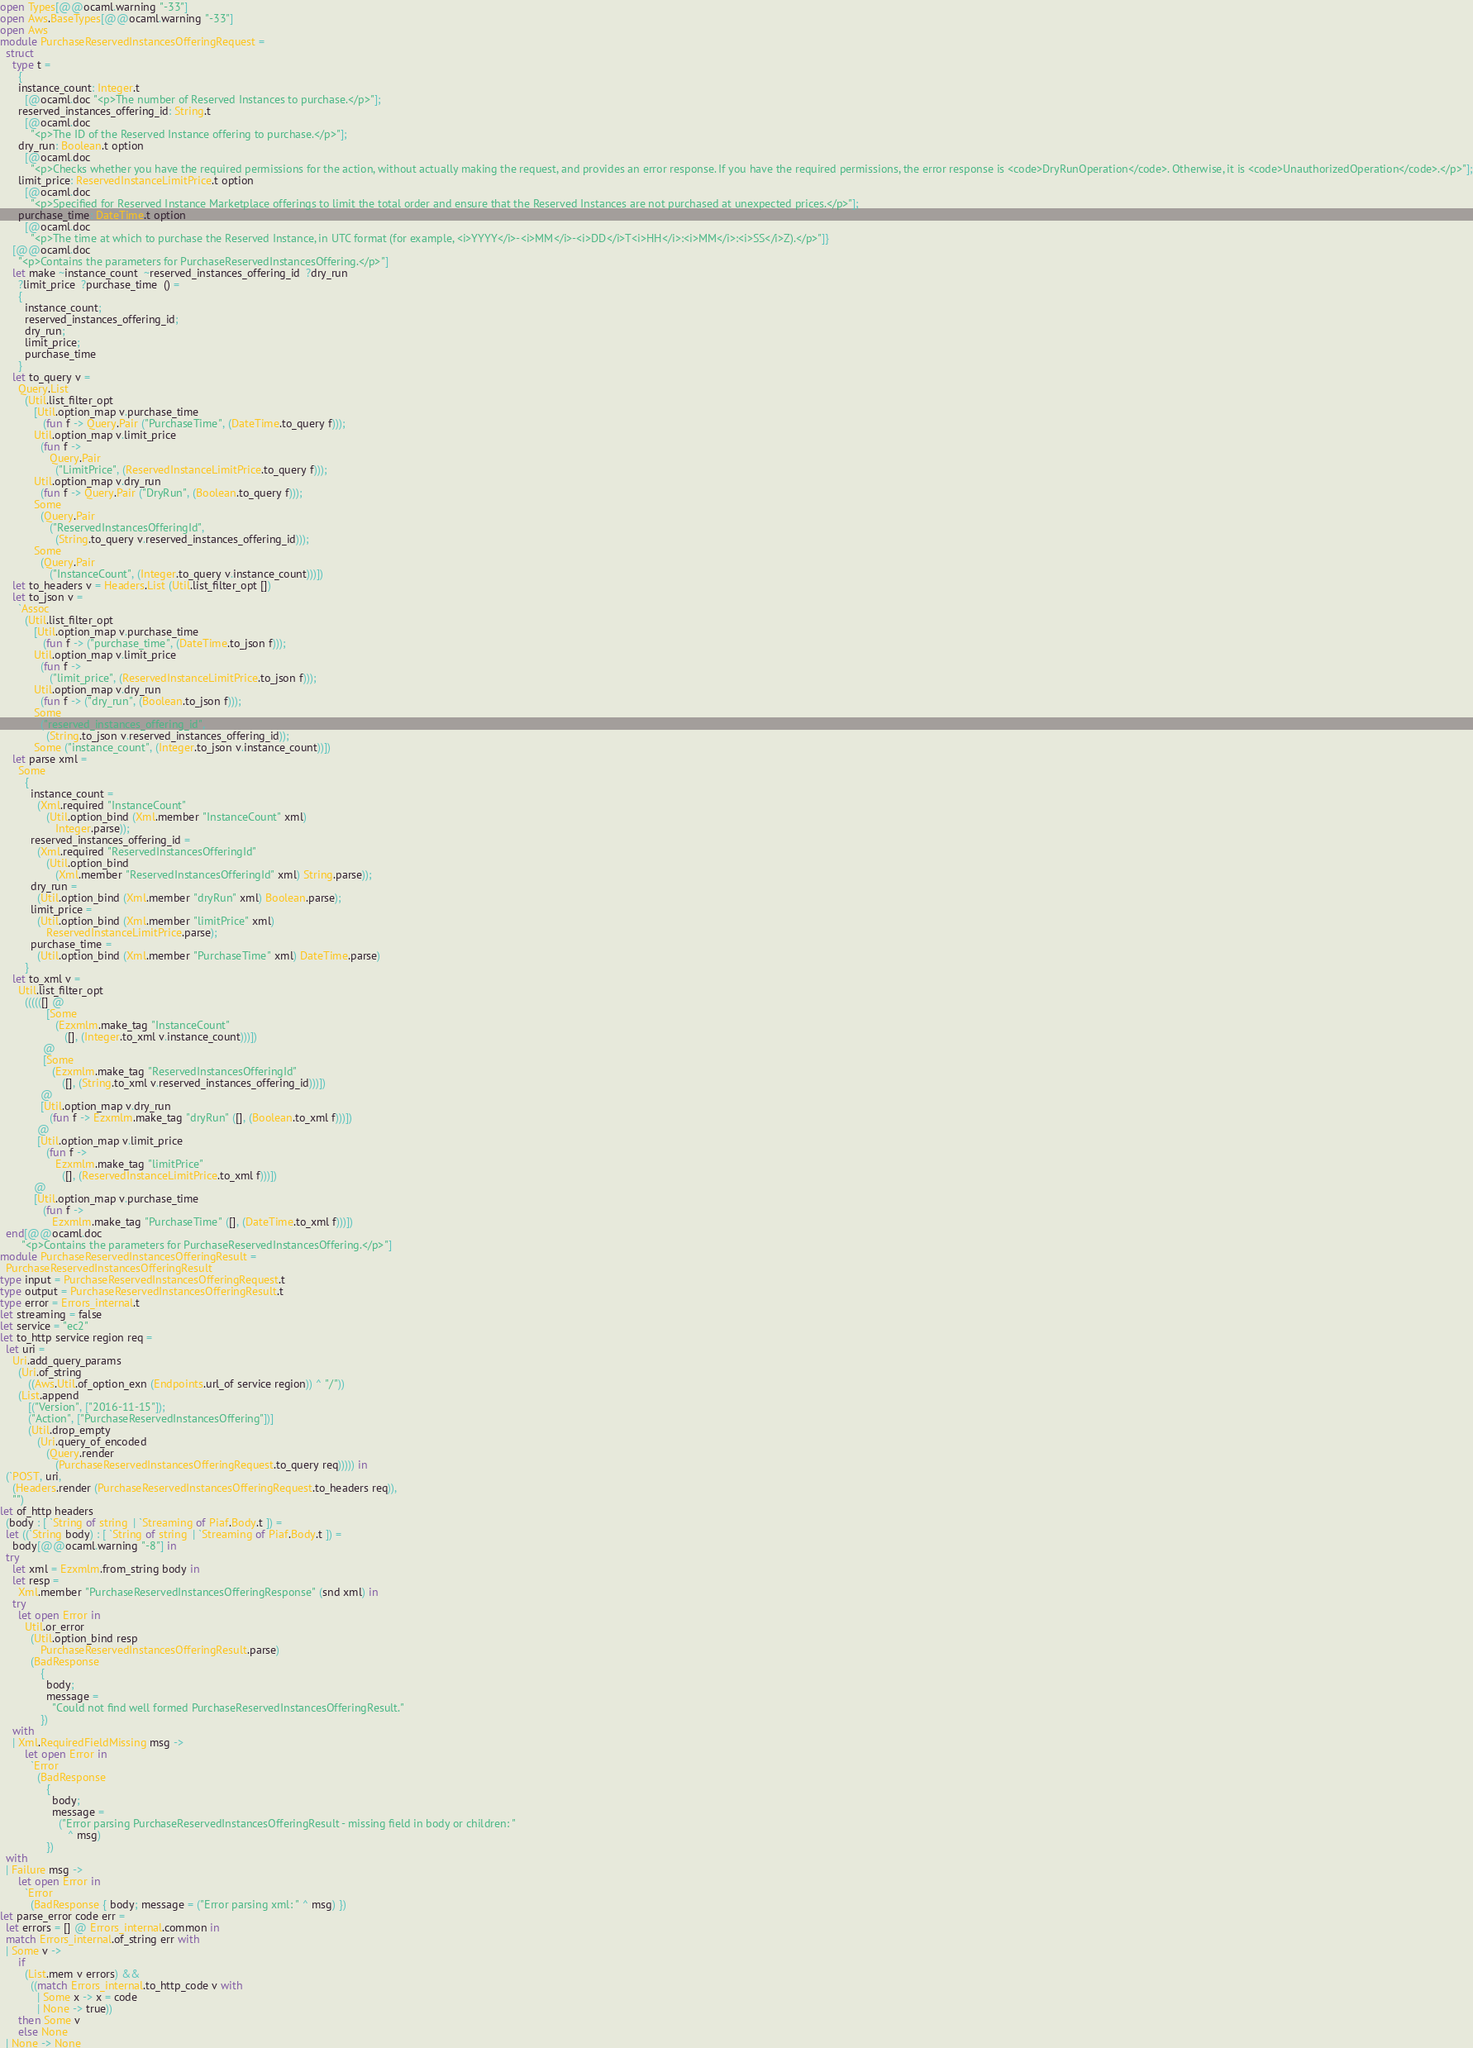Convert code to text. <code><loc_0><loc_0><loc_500><loc_500><_OCaml_>open Types[@@ocaml.warning "-33"]
open Aws.BaseTypes[@@ocaml.warning "-33"]
open Aws
module PurchaseReservedInstancesOfferingRequest =
  struct
    type t =
      {
      instance_count: Integer.t
        [@ocaml.doc "<p>The number of Reserved Instances to purchase.</p>"];
      reserved_instances_offering_id: String.t
        [@ocaml.doc
          "<p>The ID of the Reserved Instance offering to purchase.</p>"];
      dry_run: Boolean.t option
        [@ocaml.doc
          "<p>Checks whether you have the required permissions for the action, without actually making the request, and provides an error response. If you have the required permissions, the error response is <code>DryRunOperation</code>. Otherwise, it is <code>UnauthorizedOperation</code>.</p>"];
      limit_price: ReservedInstanceLimitPrice.t option
        [@ocaml.doc
          "<p>Specified for Reserved Instance Marketplace offerings to limit the total order and ensure that the Reserved Instances are not purchased at unexpected prices.</p>"];
      purchase_time: DateTime.t option
        [@ocaml.doc
          "<p>The time at which to purchase the Reserved Instance, in UTC format (for example, <i>YYYY</i>-<i>MM</i>-<i>DD</i>T<i>HH</i>:<i>MM</i>:<i>SS</i>Z).</p>"]}
    [@@ocaml.doc
      "<p>Contains the parameters for PurchaseReservedInstancesOffering.</p>"]
    let make ~instance_count  ~reserved_instances_offering_id  ?dry_run 
      ?limit_price  ?purchase_time  () =
      {
        instance_count;
        reserved_instances_offering_id;
        dry_run;
        limit_price;
        purchase_time
      }
    let to_query v =
      Query.List
        (Util.list_filter_opt
           [Util.option_map v.purchase_time
              (fun f -> Query.Pair ("PurchaseTime", (DateTime.to_query f)));
           Util.option_map v.limit_price
             (fun f ->
                Query.Pair
                  ("LimitPrice", (ReservedInstanceLimitPrice.to_query f)));
           Util.option_map v.dry_run
             (fun f -> Query.Pair ("DryRun", (Boolean.to_query f)));
           Some
             (Query.Pair
                ("ReservedInstancesOfferingId",
                  (String.to_query v.reserved_instances_offering_id)));
           Some
             (Query.Pair
                ("InstanceCount", (Integer.to_query v.instance_count)))])
    let to_headers v = Headers.List (Util.list_filter_opt [])
    let to_json v =
      `Assoc
        (Util.list_filter_opt
           [Util.option_map v.purchase_time
              (fun f -> ("purchase_time", (DateTime.to_json f)));
           Util.option_map v.limit_price
             (fun f ->
                ("limit_price", (ReservedInstanceLimitPrice.to_json f)));
           Util.option_map v.dry_run
             (fun f -> ("dry_run", (Boolean.to_json f)));
           Some
             ("reserved_instances_offering_id",
               (String.to_json v.reserved_instances_offering_id));
           Some ("instance_count", (Integer.to_json v.instance_count))])
    let parse xml =
      Some
        {
          instance_count =
            (Xml.required "InstanceCount"
               (Util.option_bind (Xml.member "InstanceCount" xml)
                  Integer.parse));
          reserved_instances_offering_id =
            (Xml.required "ReservedInstancesOfferingId"
               (Util.option_bind
                  (Xml.member "ReservedInstancesOfferingId" xml) String.parse));
          dry_run =
            (Util.option_bind (Xml.member "dryRun" xml) Boolean.parse);
          limit_price =
            (Util.option_bind (Xml.member "limitPrice" xml)
               ReservedInstanceLimitPrice.parse);
          purchase_time =
            (Util.option_bind (Xml.member "PurchaseTime" xml) DateTime.parse)
        }
    let to_xml v =
      Util.list_filter_opt
        ((((([] @
               [Some
                  (Ezxmlm.make_tag "InstanceCount"
                     ([], (Integer.to_xml v.instance_count)))])
              @
              [Some
                 (Ezxmlm.make_tag "ReservedInstancesOfferingId"
                    ([], (String.to_xml v.reserved_instances_offering_id)))])
             @
             [Util.option_map v.dry_run
                (fun f -> Ezxmlm.make_tag "dryRun" ([], (Boolean.to_xml f)))])
            @
            [Util.option_map v.limit_price
               (fun f ->
                  Ezxmlm.make_tag "limitPrice"
                    ([], (ReservedInstanceLimitPrice.to_xml f)))])
           @
           [Util.option_map v.purchase_time
              (fun f ->
                 Ezxmlm.make_tag "PurchaseTime" ([], (DateTime.to_xml f)))])
  end[@@ocaml.doc
       "<p>Contains the parameters for PurchaseReservedInstancesOffering.</p>"]
module PurchaseReservedInstancesOfferingResult =
  PurchaseReservedInstancesOfferingResult
type input = PurchaseReservedInstancesOfferingRequest.t
type output = PurchaseReservedInstancesOfferingResult.t
type error = Errors_internal.t
let streaming = false
let service = "ec2"
let to_http service region req =
  let uri =
    Uri.add_query_params
      (Uri.of_string
         ((Aws.Util.of_option_exn (Endpoints.url_of service region)) ^ "/"))
      (List.append
         [("Version", ["2016-11-15"]);
         ("Action", ["PurchaseReservedInstancesOffering"])]
         (Util.drop_empty
            (Uri.query_of_encoded
               (Query.render
                  (PurchaseReservedInstancesOfferingRequest.to_query req))))) in
  (`POST, uri,
    (Headers.render (PurchaseReservedInstancesOfferingRequest.to_headers req)),
    "")
let of_http headers
  (body : [ `String of string  | `Streaming of Piaf.Body.t ]) =
  let ((`String body) : [ `String of string  | `Streaming of Piaf.Body.t ]) =
    body[@@ocaml.warning "-8"] in
  try
    let xml = Ezxmlm.from_string body in
    let resp =
      Xml.member "PurchaseReservedInstancesOfferingResponse" (snd xml) in
    try
      let open Error in
        Util.or_error
          (Util.option_bind resp
             PurchaseReservedInstancesOfferingResult.parse)
          (BadResponse
             {
               body;
               message =
                 "Could not find well formed PurchaseReservedInstancesOfferingResult."
             })
    with
    | Xml.RequiredFieldMissing msg ->
        let open Error in
          `Error
            (BadResponse
               {
                 body;
                 message =
                   ("Error parsing PurchaseReservedInstancesOfferingResult - missing field in body or children: "
                      ^ msg)
               })
  with
  | Failure msg ->
      let open Error in
        `Error
          (BadResponse { body; message = ("Error parsing xml: " ^ msg) })
let parse_error code err =
  let errors = [] @ Errors_internal.common in
  match Errors_internal.of_string err with
  | Some v ->
      if
        (List.mem v errors) &&
          ((match Errors_internal.to_http_code v with
            | Some x -> x = code
            | None -> true))
      then Some v
      else None
  | None -> None</code> 